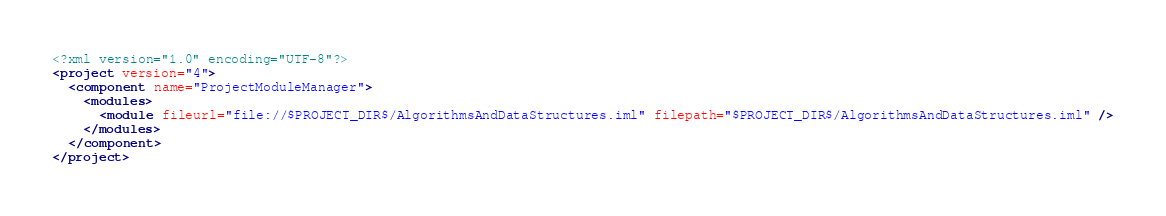Convert code to text. <code><loc_0><loc_0><loc_500><loc_500><_XML_><?xml version="1.0" encoding="UTF-8"?>
<project version="4">
  <component name="ProjectModuleManager">
    <modules>
      <module fileurl="file://$PROJECT_DIR$/AlgorithmsAndDataStructures.iml" filepath="$PROJECT_DIR$/AlgorithmsAndDataStructures.iml" />
    </modules>
  </component>
</project></code> 